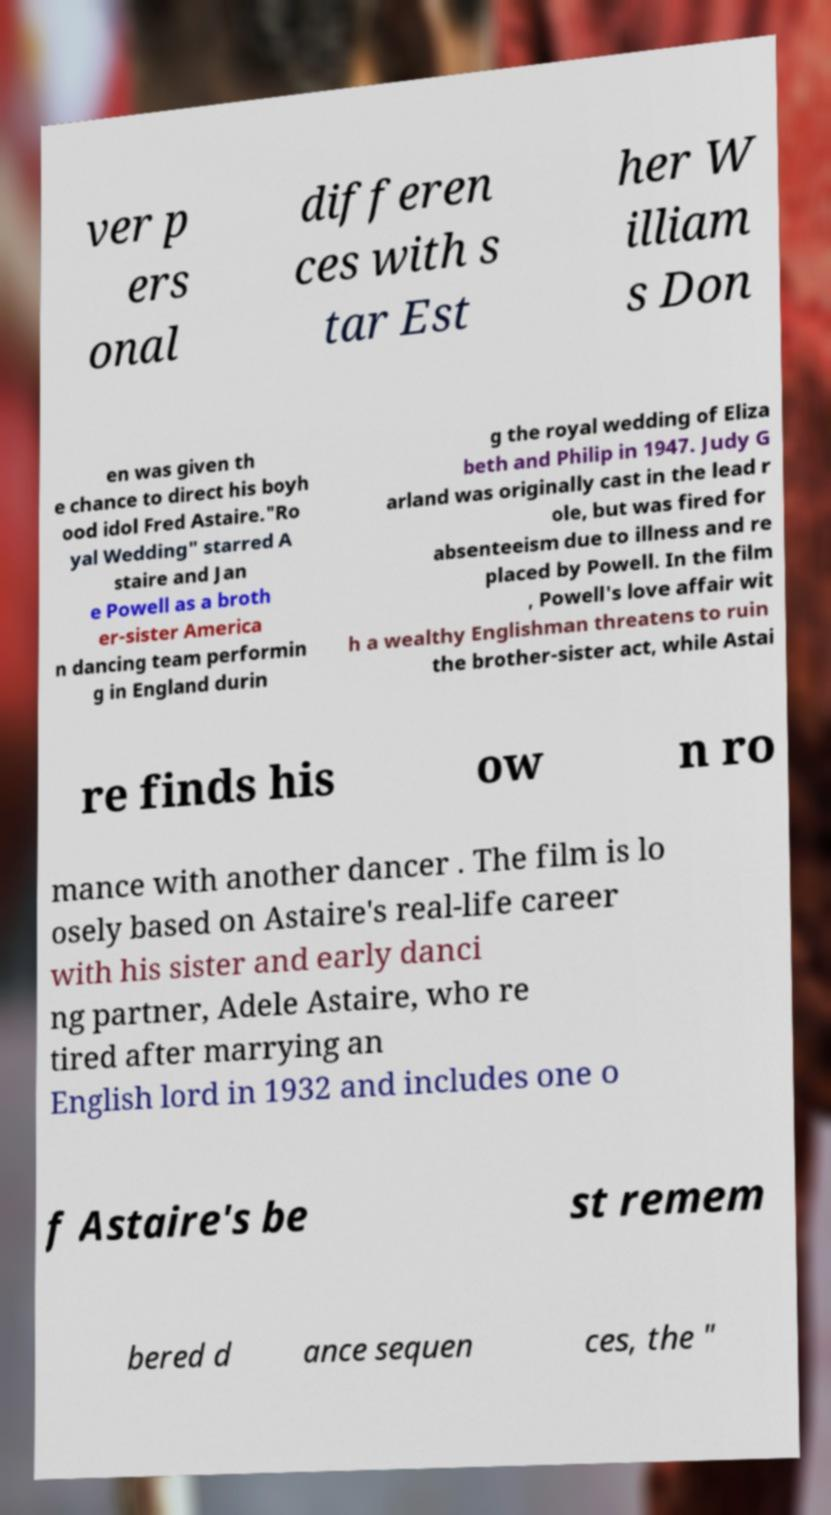What messages or text are displayed in this image? I need them in a readable, typed format. ver p ers onal differen ces with s tar Est her W illiam s Don en was given th e chance to direct his boyh ood idol Fred Astaire."Ro yal Wedding" starred A staire and Jan e Powell as a broth er-sister America n dancing team performin g in England durin g the royal wedding of Eliza beth and Philip in 1947. Judy G arland was originally cast in the lead r ole, but was fired for absenteeism due to illness and re placed by Powell. In the film , Powell's love affair wit h a wealthy Englishman threatens to ruin the brother-sister act, while Astai re finds his ow n ro mance with another dancer . The film is lo osely based on Astaire's real-life career with his sister and early danci ng partner, Adele Astaire, who re tired after marrying an English lord in 1932 and includes one o f Astaire's be st remem bered d ance sequen ces, the " 